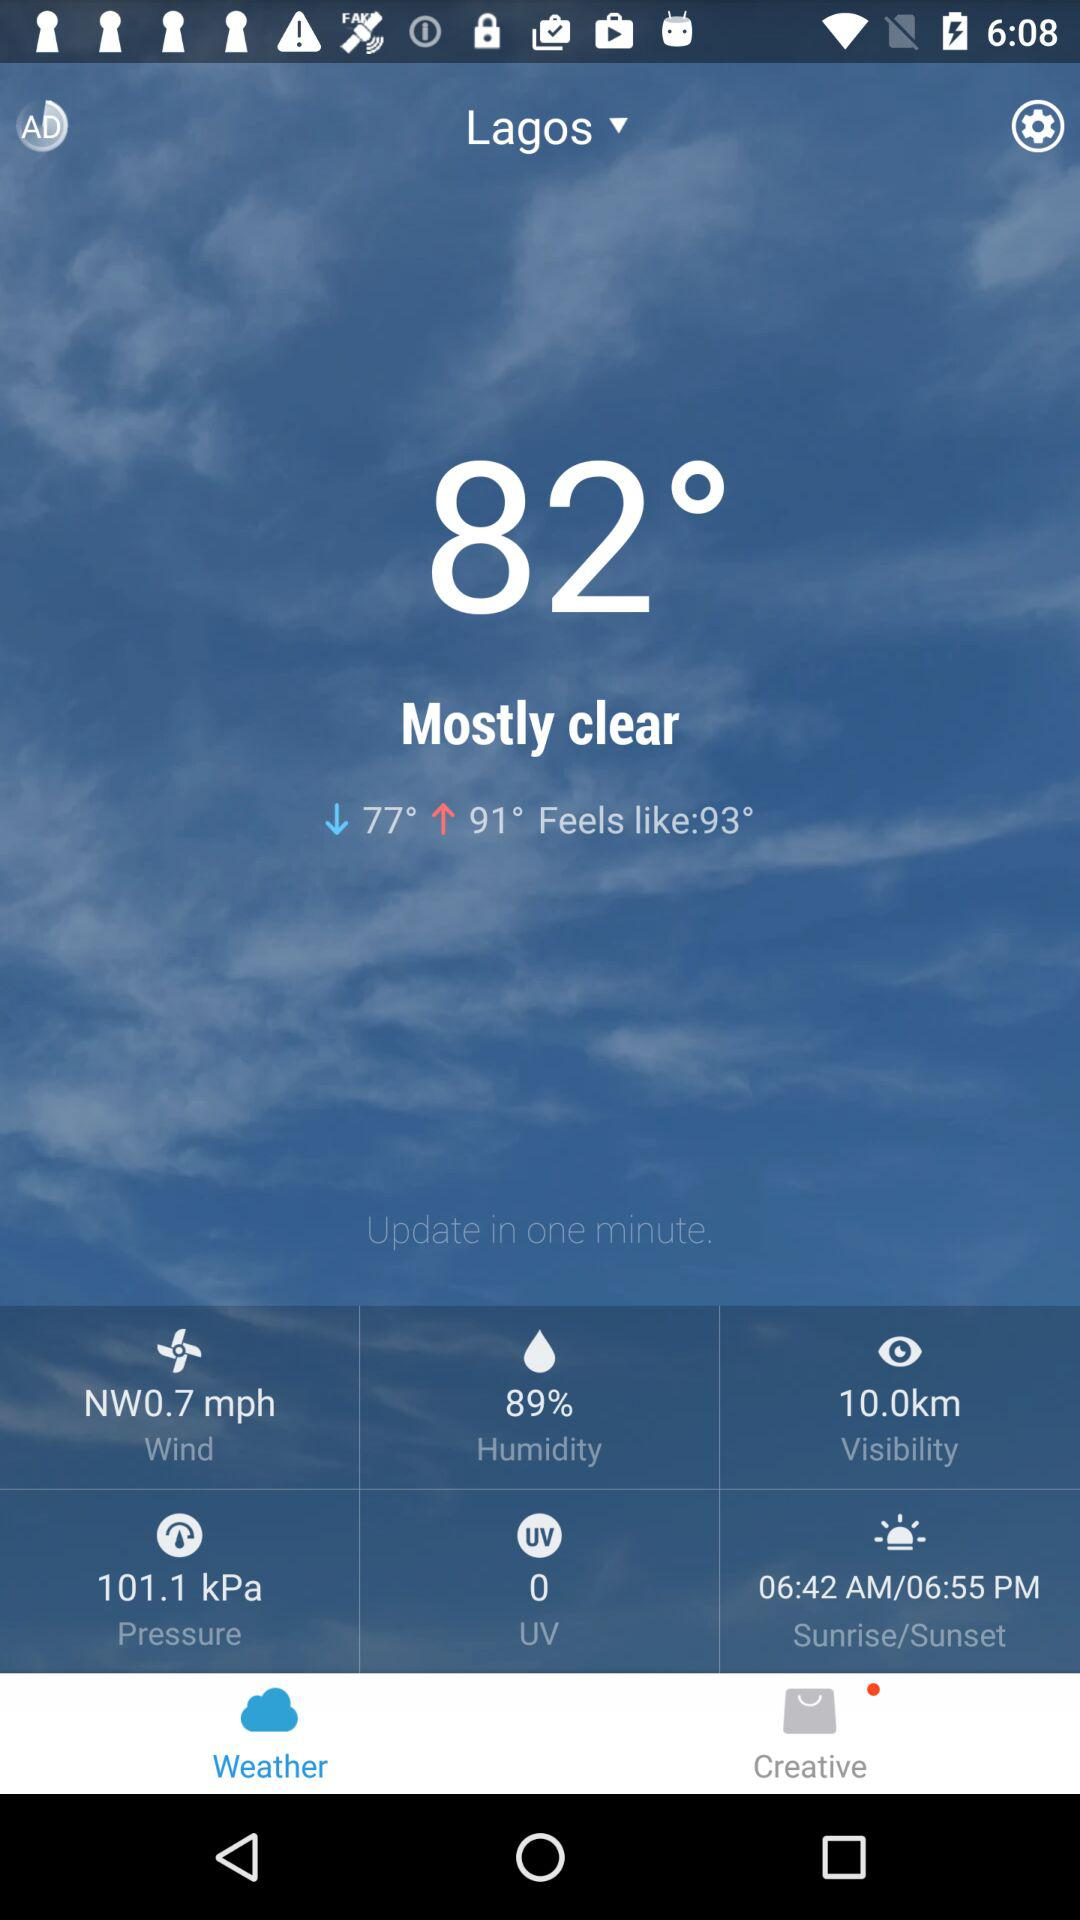What is the difference in temperature between the low and high temperatures?
Answer the question using a single word or phrase. 14 